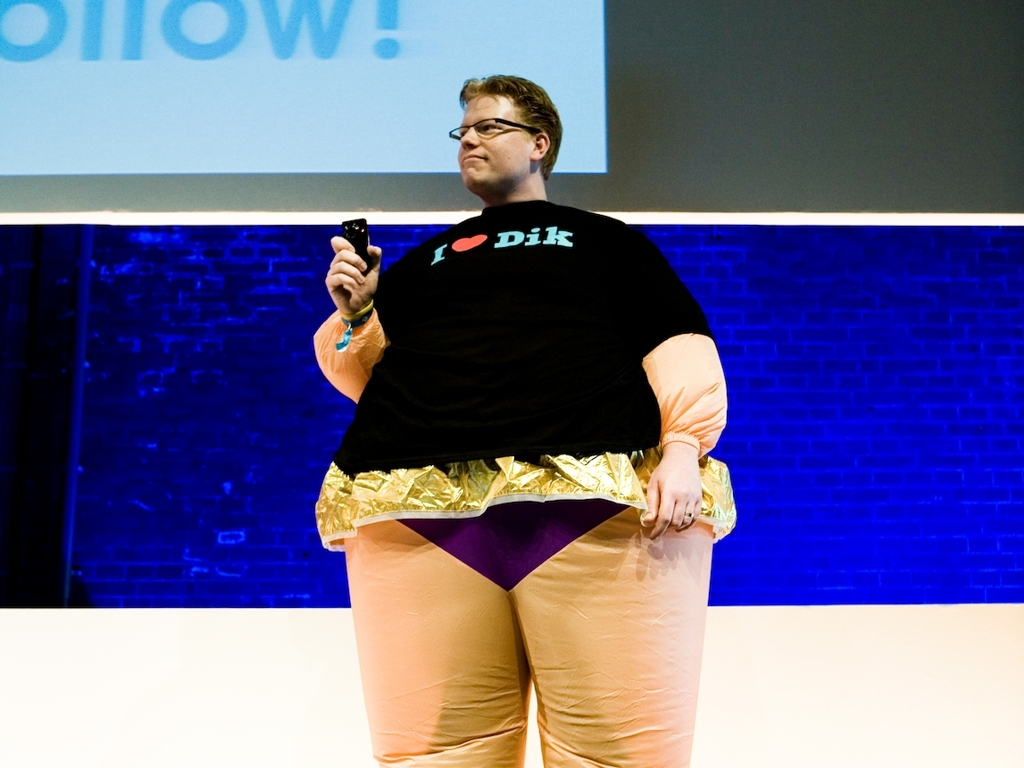Are there any quality issues with this image? Yes, the image is suffering from several quality issues such as noticeable pixelation and compression artifacts. The subject's feet are cropped out of the frame, and the lighting appears uneven, which detracts from the overall clarity and detail of the photograph. 